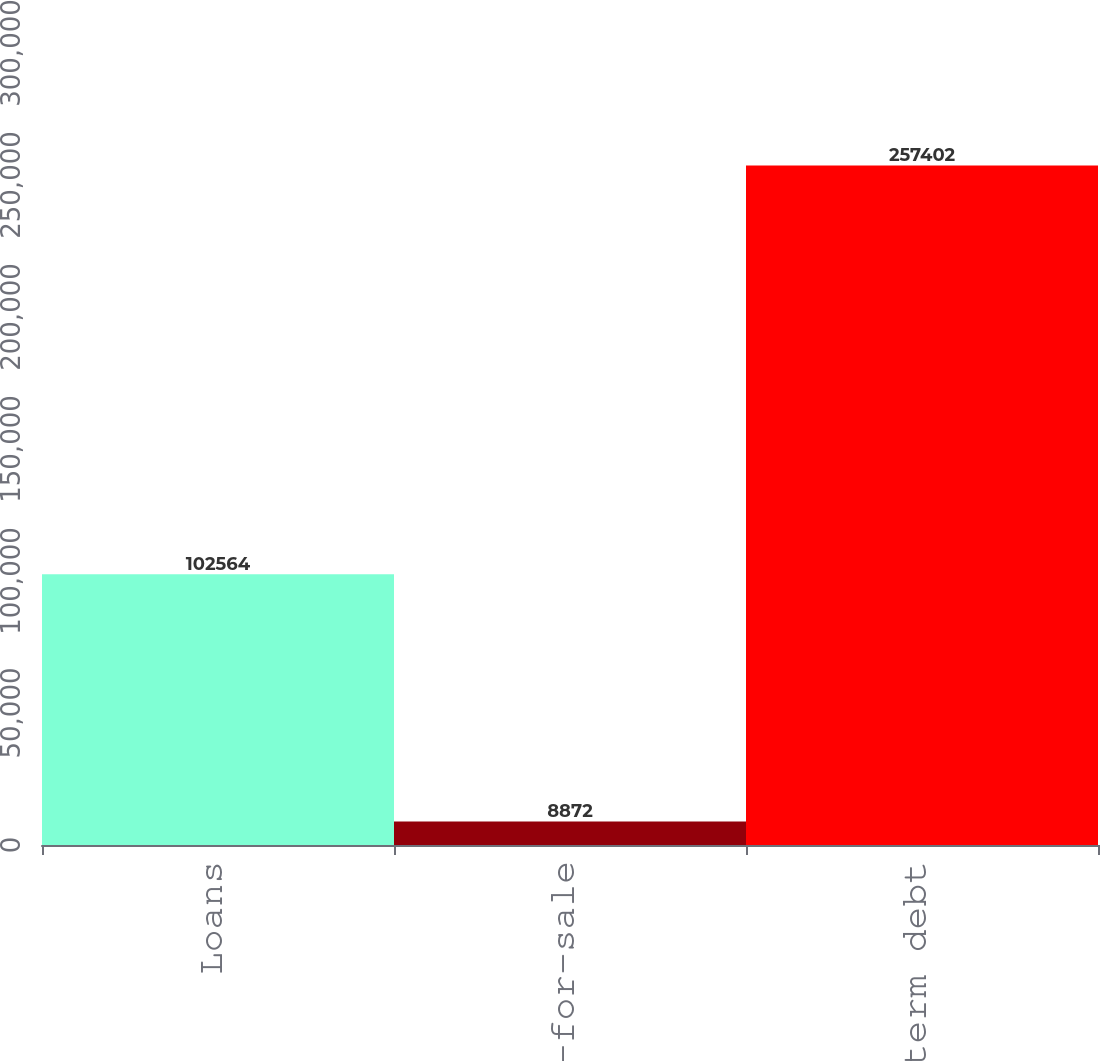Convert chart to OTSL. <chart><loc_0><loc_0><loc_500><loc_500><bar_chart><fcel>Loans<fcel>Loans held-for-sale<fcel>Long-term debt<nl><fcel>102564<fcel>8872<fcel>257402<nl></chart> 